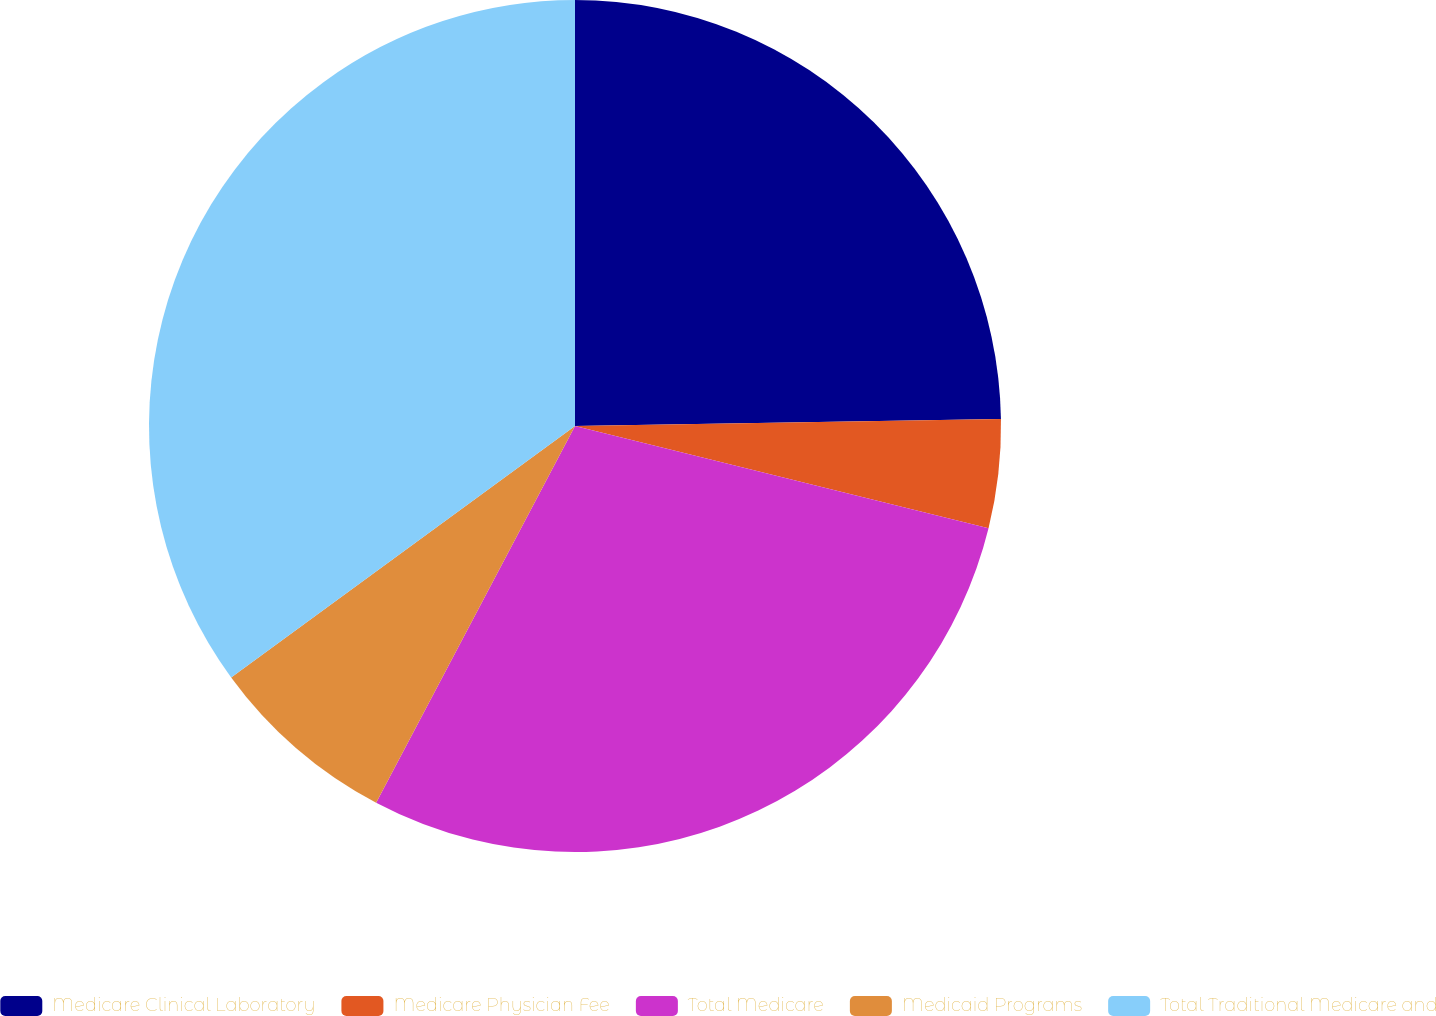Convert chart to OTSL. <chart><loc_0><loc_0><loc_500><loc_500><pie_chart><fcel>Medicare Clinical Laboratory<fcel>Medicare Physician Fee<fcel>Total Medicare<fcel>Medicaid Programs<fcel>Total Traditional Medicare and<nl><fcel>24.74%<fcel>4.12%<fcel>28.87%<fcel>7.22%<fcel>35.05%<nl></chart> 